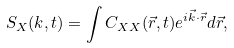<formula> <loc_0><loc_0><loc_500><loc_500>S _ { X } ( k , t ) = \int C _ { X X } ( \vec { r } , t ) e ^ { i \vec { k } \cdot \vec { r } } d \vec { r } ,</formula> 